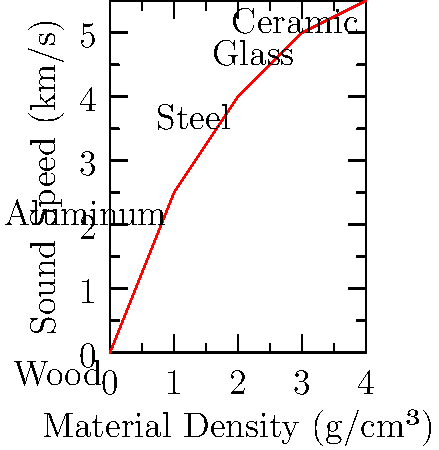In your DIY instrument workshop, you're experimenting with different materials for creating unique sound propagation. The graph shows the relationship between material density and sound speed for various materials. If you're aiming to create an instrument with the fastest sound propagation, which material should you choose, and what is the approximate speed of sound in that material? To solve this problem, let's analyze the graph step-by-step:

1. The graph shows the relationship between material density (x-axis) and sound speed (y-axis) for different materials used in DIY instruments.

2. The materials shown are:
   - Wood (lowest density)
   - Aluminum
   - Steel
   - Glass
   - Ceramic (highest density)

3. To find the material with the fastest sound propagation, we need to identify the highest point on the y-axis (sound speed).

4. Examining the graph, we can see that the line reaches its maximum height at the rightmost point, which corresponds to ceramic.

5. To determine the approximate speed of sound in ceramic, we need to read the y-value for the ceramic data point.

6. The y-value for ceramic is approximately 5.5 on the scale.

7. The y-axis is labeled "Sound Speed (km/s)", so the unit for the speed is kilometers per second.

Therefore, ceramic has the fastest sound propagation among the materials shown, with a speed of approximately 5.5 km/s.
Answer: Ceramic, 5.5 km/s 